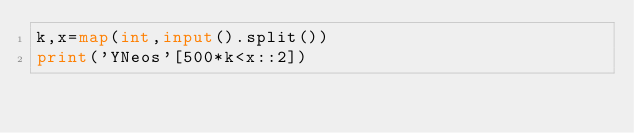Convert code to text. <code><loc_0><loc_0><loc_500><loc_500><_Python_>k,x=map(int,input().split())
print('YNeos'[500*k<x::2])</code> 